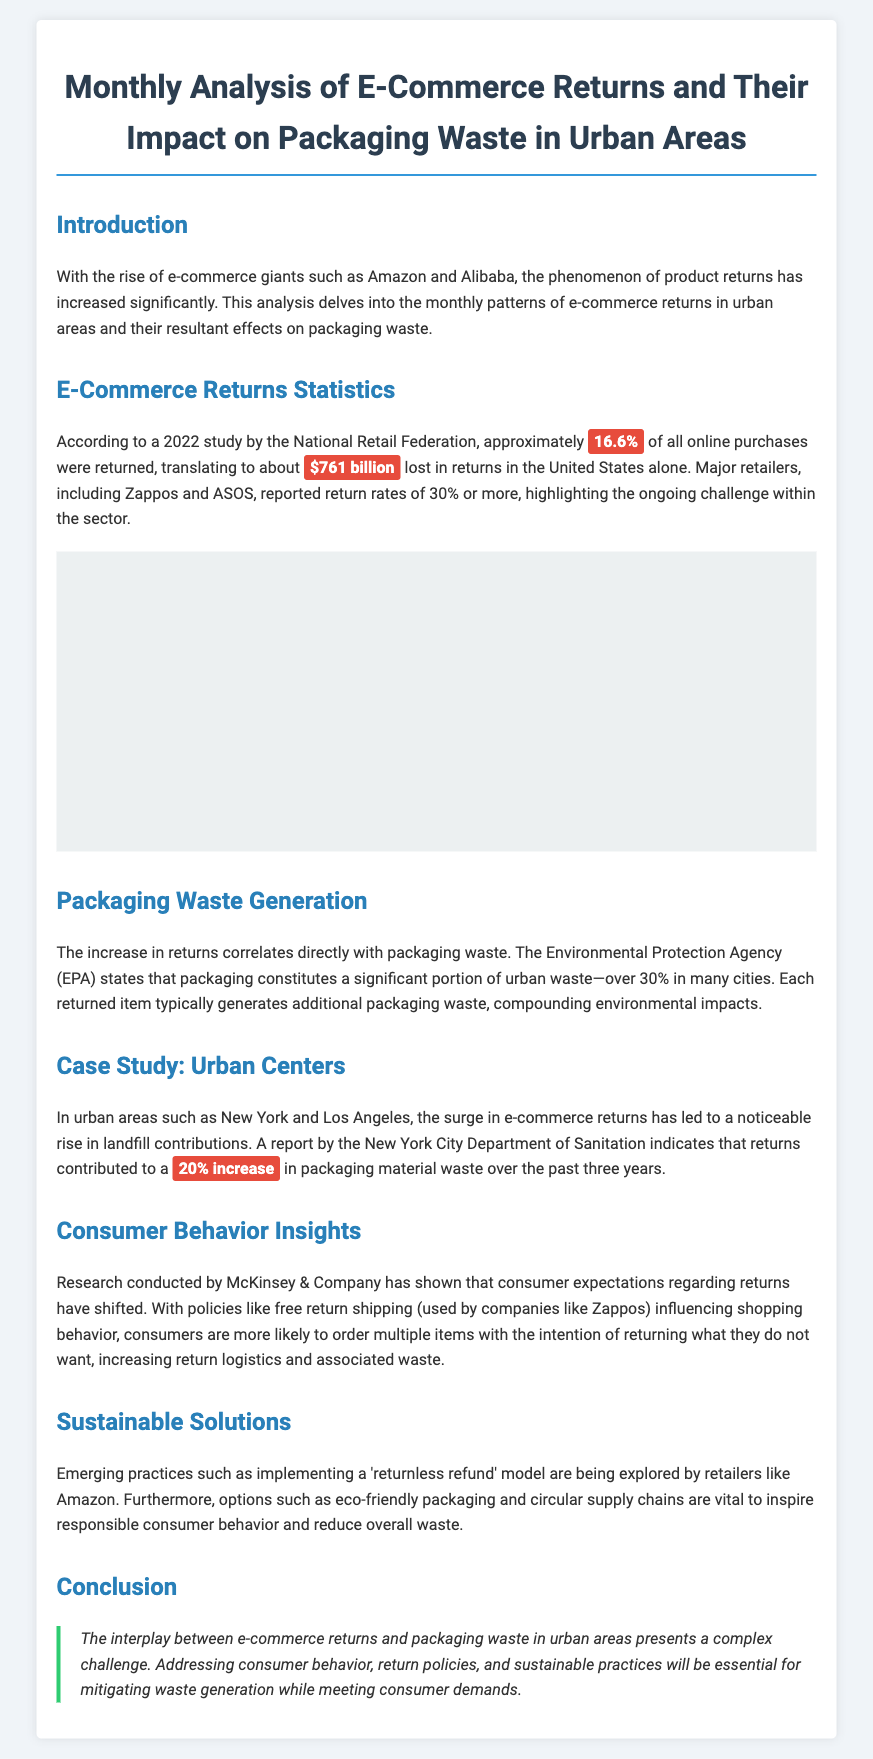what percentage of online purchases were returned? The document states that approximately 16.6% of all online purchases were returned according to a 2022 study.
Answer: 16.6% what was the amount lost in returns in the United States? The document mentions that about $761 billion was lost in returns in the United States alone.
Answer: $761 billion which retailer reported a return rate of 30% or more? The document specifically highlights Zappos and ASOS as retailers that reported return rates of 30% or more.
Answer: Zappos, ASOS how much has packaging material waste increased in New York due to returns? The report states that returns contributed to a 20% increase in packaging material waste over the past three years.
Answer: 20% what practice is being explored to reduce returns waste? The document mentions that the 'returnless refund' model is an emerging practice being explored by retailers.
Answer: returnless refund what percentage of urban waste does packaging constitute? According to the Environmental Protection Agency, packaging constitutes over 30% of urban waste in many cities.
Answer: over 30% who conducted research on consumer expectations regarding returns? The document states that research was conducted by McKinsey & Company regarding consumer expectations.
Answer: McKinsey & Company what colors are used for the main headings in the document? The document uses specific colors for main headings, with #2980b9 for h2 headings and #2c3e50 for h1 headings.
Answer: #2980b9, #2c3e50 